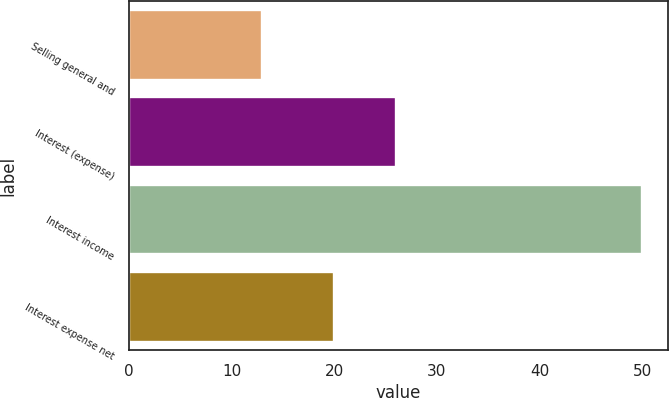Convert chart. <chart><loc_0><loc_0><loc_500><loc_500><bar_chart><fcel>Selling general and<fcel>Interest (expense)<fcel>Interest income<fcel>Interest expense net<nl><fcel>13<fcel>26<fcel>50<fcel>20<nl></chart> 